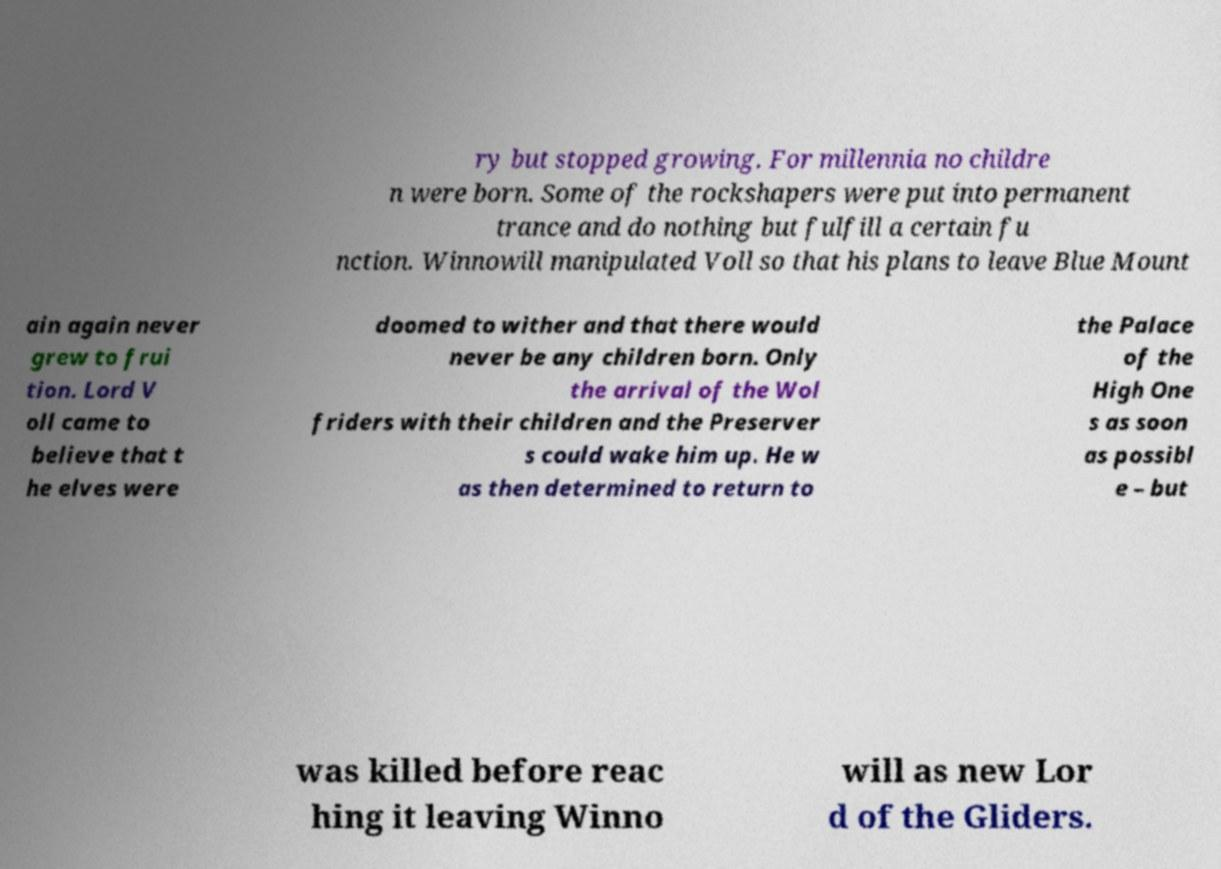Please identify and transcribe the text found in this image. ry but stopped growing. For millennia no childre n were born. Some of the rockshapers were put into permanent trance and do nothing but fulfill a certain fu nction. Winnowill manipulated Voll so that his plans to leave Blue Mount ain again never grew to frui tion. Lord V oll came to believe that t he elves were doomed to wither and that there would never be any children born. Only the arrival of the Wol friders with their children and the Preserver s could wake him up. He w as then determined to return to the Palace of the High One s as soon as possibl e – but was killed before reac hing it leaving Winno will as new Lor d of the Gliders. 